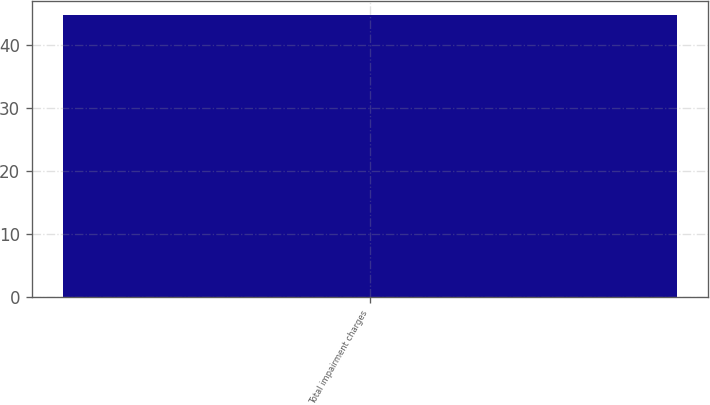Convert chart to OTSL. <chart><loc_0><loc_0><loc_500><loc_500><bar_chart><fcel>Total impairment charges<nl><fcel>44.8<nl></chart> 